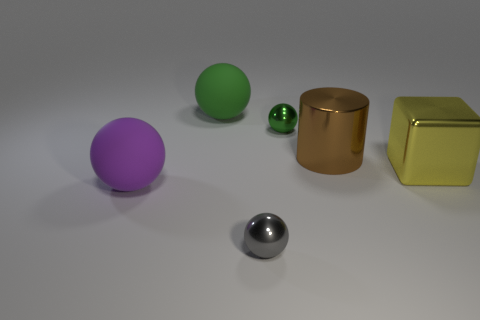Add 1 rubber cubes. How many objects exist? 7 Subtract all cylinders. How many objects are left? 5 Subtract all brown cubes. Subtract all large purple things. How many objects are left? 5 Add 2 purple rubber spheres. How many purple rubber spheres are left? 3 Add 2 purple matte cubes. How many purple matte cubes exist? 2 Subtract 1 gray spheres. How many objects are left? 5 